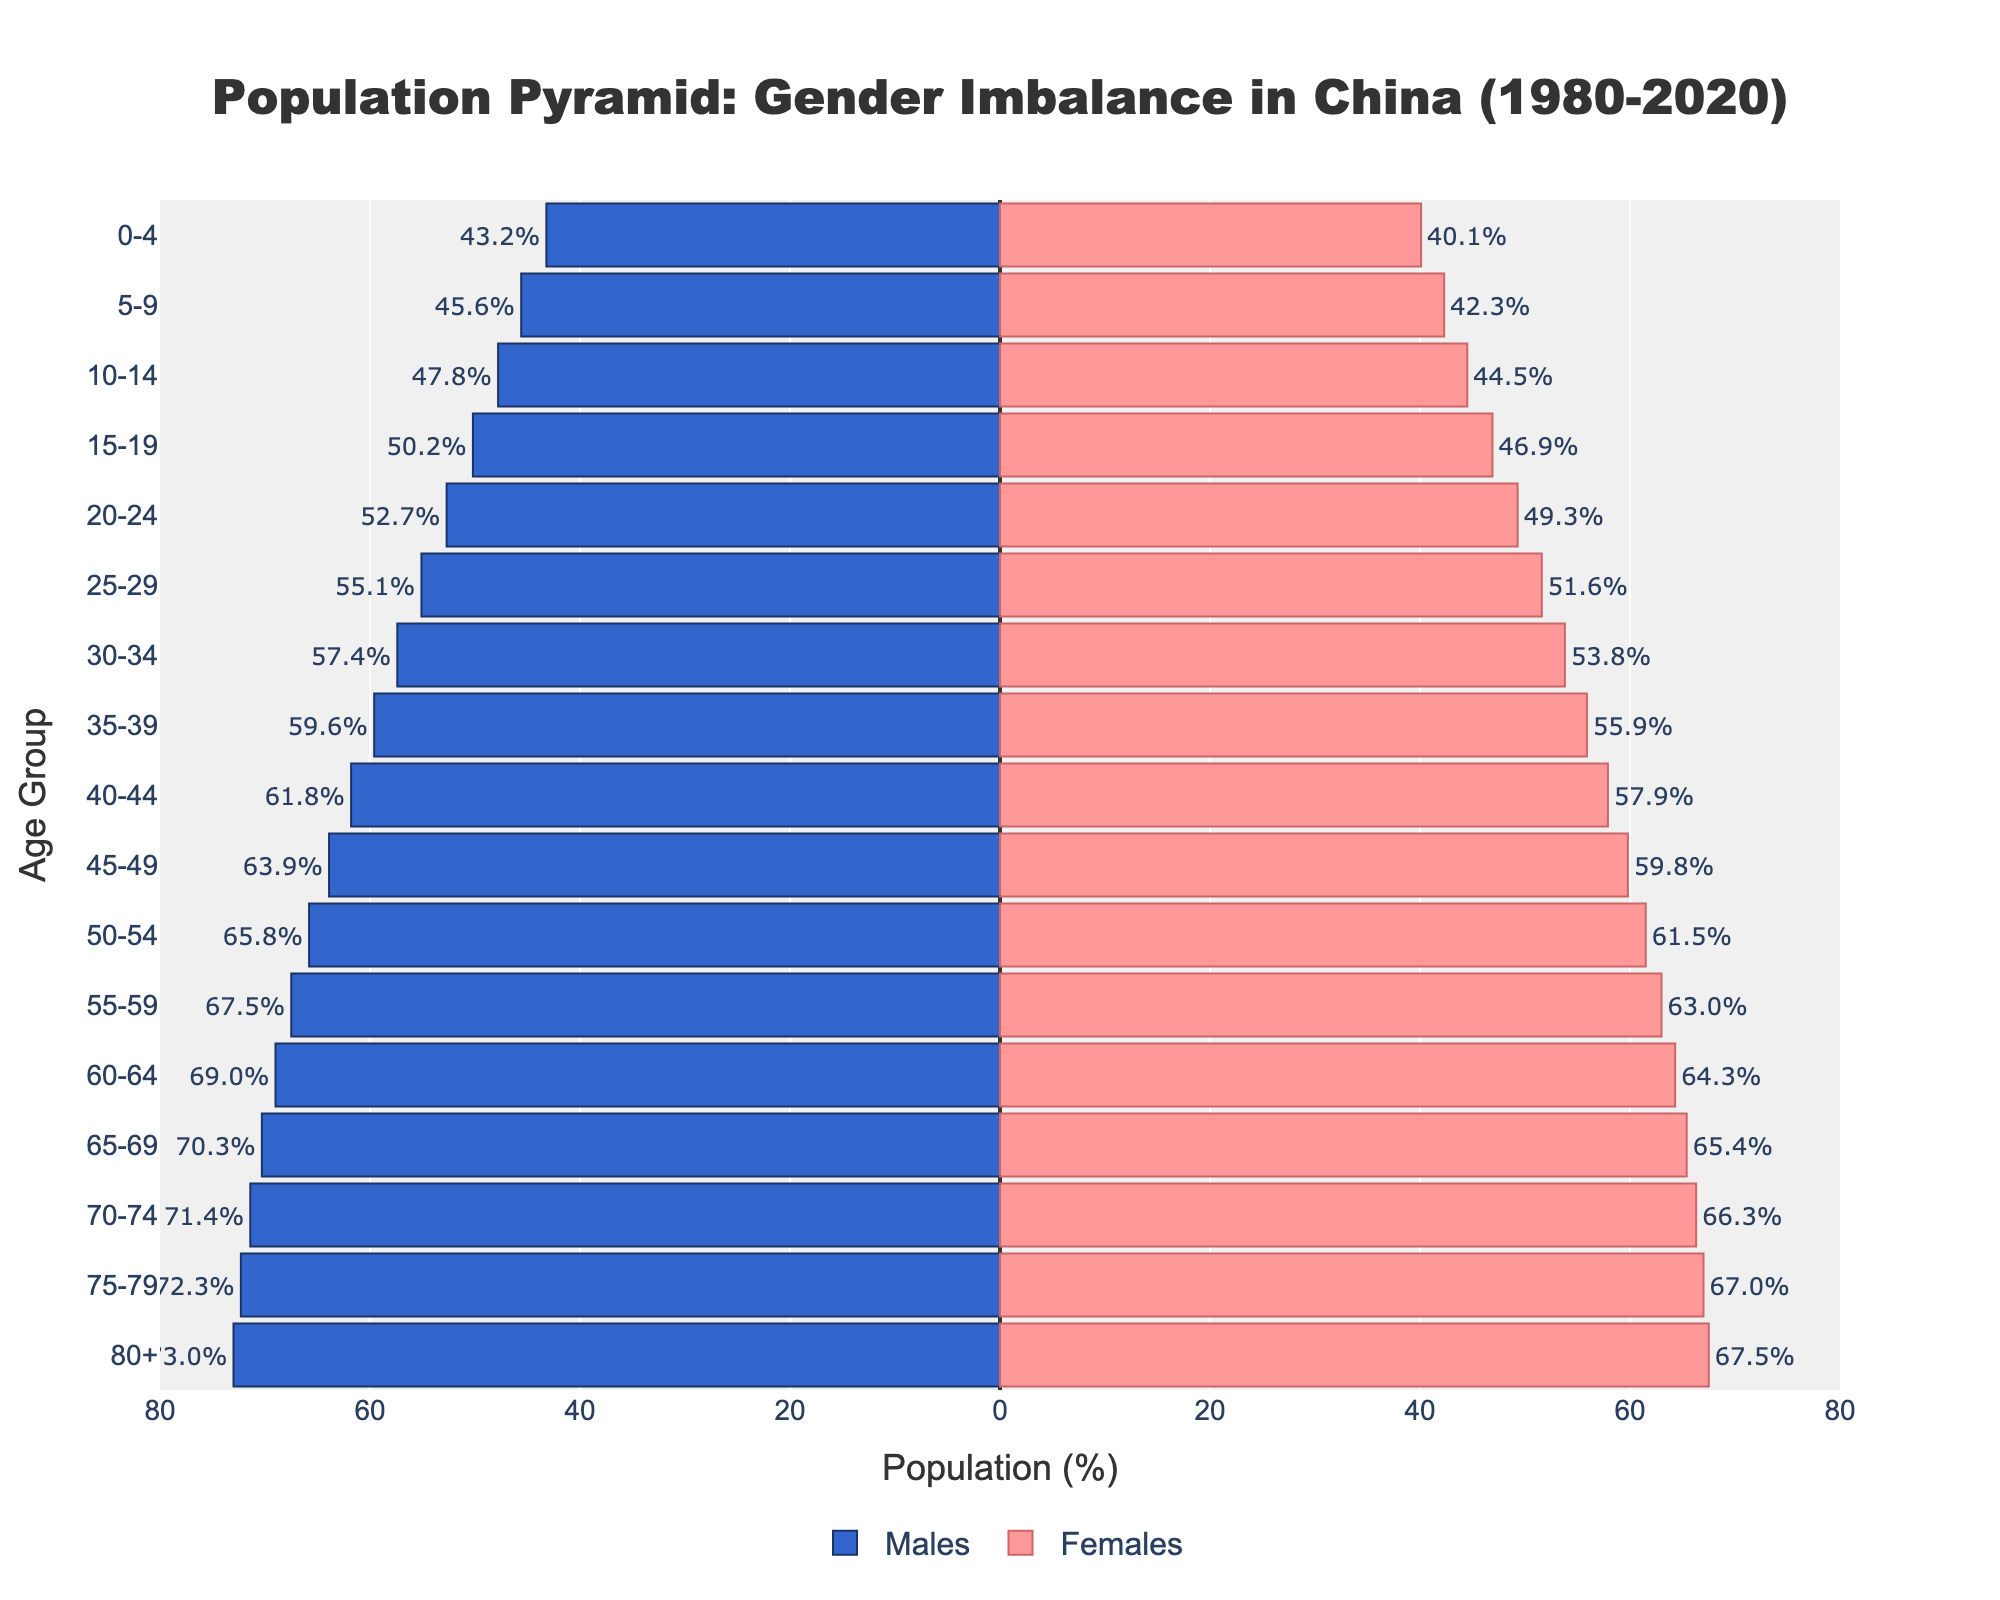What is the title of the figure? The title of the figure is displayed at the top of the plot. It reads "Population Pyramid: Gender Imbalance in China (1980-2020)".
Answer: Population Pyramid: Gender Imbalance in China (1980-2020) Which color represents the male population in the chart? The bars representing the male population are colored blue, indicated by the hovertext and the legend in the plot.
Answer: Blue What is the female population percentage in the 10-14 age group? The percentage of females in the 10-14 age group is shown next to the corresponding bar on the right side of the pyramid and can also be checked by the hover text. It is 44.5%.
Answer: 44.5% At which age group is the gender imbalance the highest? To determine the age group with the highest gender imbalance, look at the differences between the lengths of the bars for males and females across all age groups. The age group with the largest difference is 80+, where males (73.0%) surpass females (67.5%).
Answer: 80+ How many age groups have a male population percentage that exceeds 60%? Check the bars for males on the left side of the pyramid and count how many of them exceed the 60% mark. These age groups are 40-44, 45-49, 50-54, 55-59, 60-64, 65-69, 70-74, 75-79, and 80+. This totals 9 age groups.
Answer: 9 What is the difference in population percentage between males and females in the 0-4 age group? Subtract the percentage of females (40.1%) from the percentage of males (43.2%) in the 0-4 age group. The difference is 43.2% - 40.1% = 3.1%.
Answer: 3.1% Which age group has the smallest gender imbalance? The smallest gender imbalance can be identified by finding the age group where the difference between male and female percentages is the smallest. For the 70-74 age group, the percentages are 71.4% males and 66.3% females, giving a difference of 5.1%. This is the smallest difference compared to other age groups.
Answer: 70-74 How does the gender imbalance trend as the age increases? Examine the plot's distribution of percentages for both males and females across all age groups. Notice that the male percentage generally increases at a higher rate with age compared to females, resulting in a widening gender imbalance as age increases.
Answer: The gender imbalance increases with age 